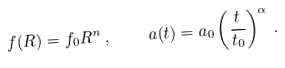Convert formula to latex. <formula><loc_0><loc_0><loc_500><loc_500>f ( R ) = f _ { 0 } R ^ { n } \, , \quad a ( t ) = a _ { 0 } \left ( \frac { t } { t _ { 0 } } \right ) ^ { \alpha } \, .</formula> 